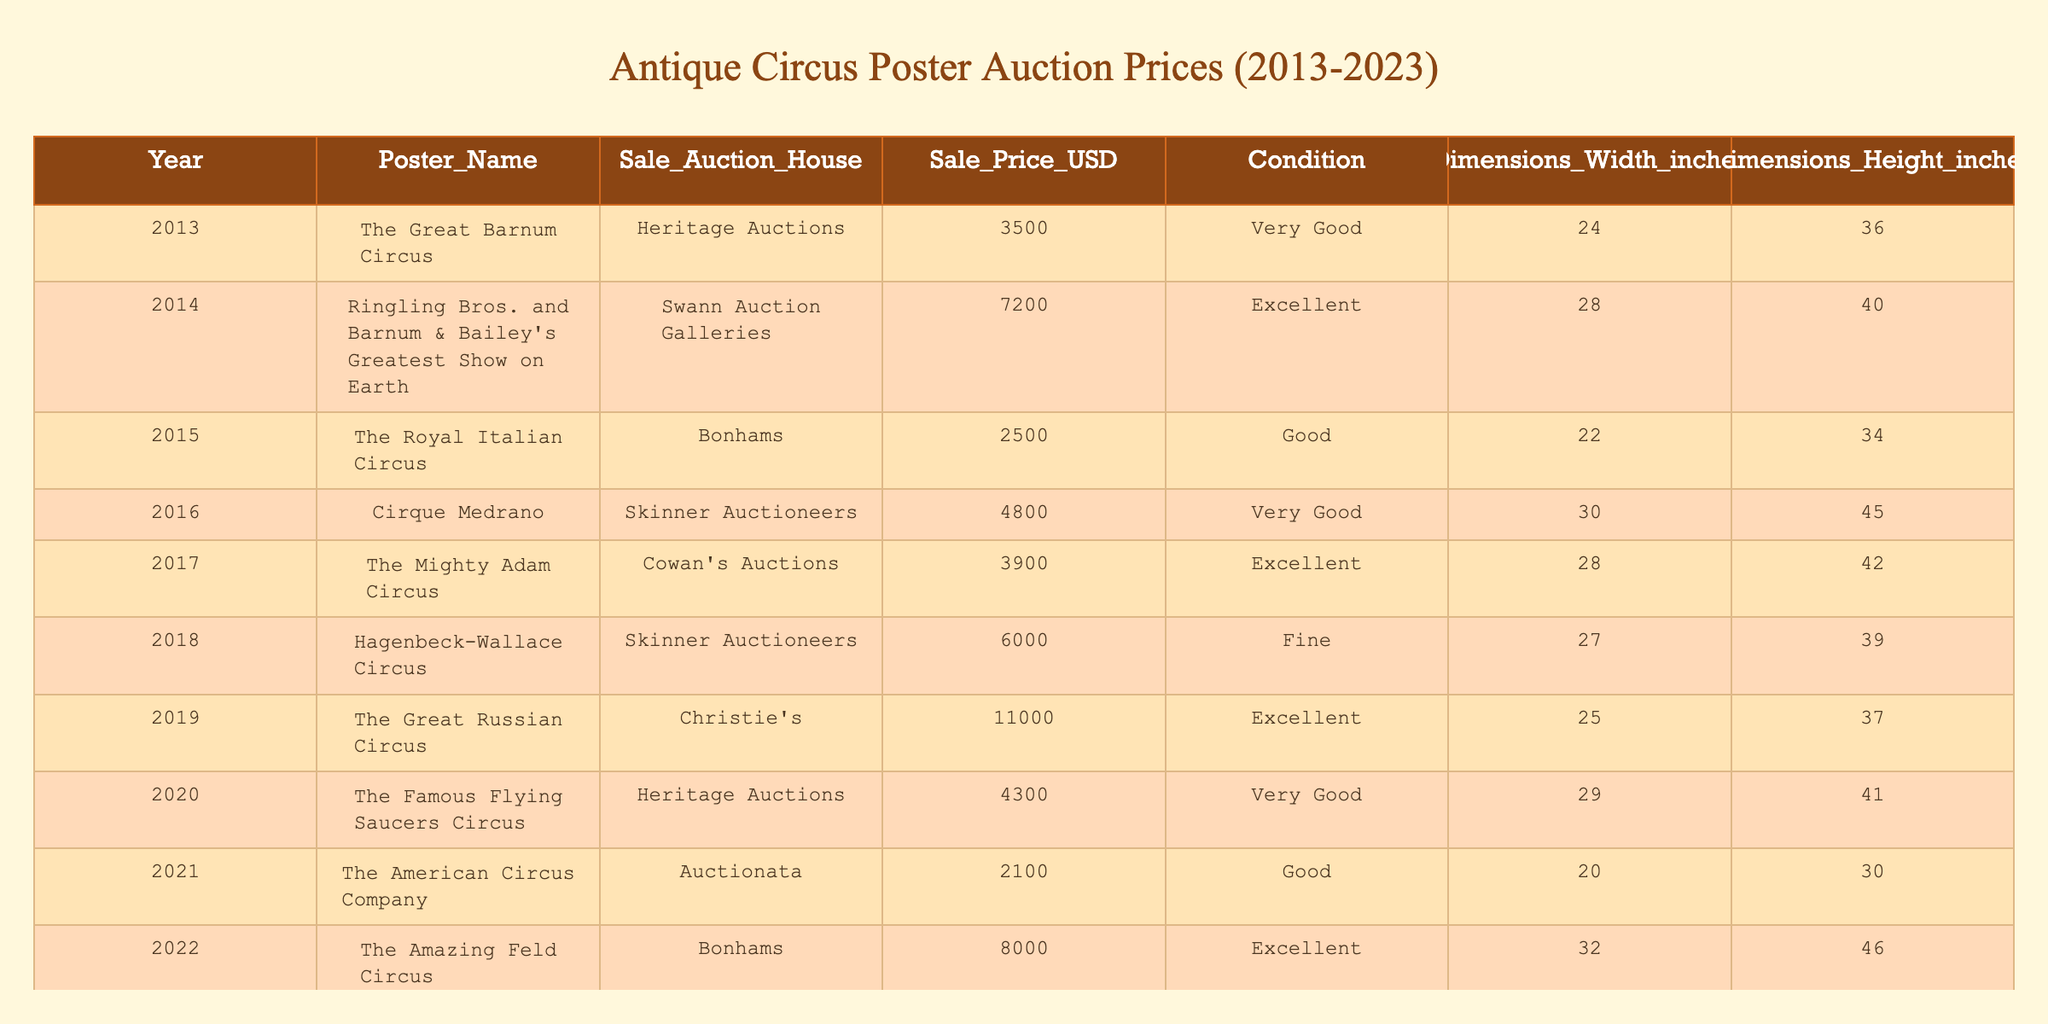What was the sale price of "The Great Russian Circus"? The table shows that "The Great Russian Circus" was sold for 11,000 USD in 2019.
Answer: 11,000 USD What condition was "Daring Diggers Circus" in when it was sold? According to the table, "Daring Diggers Circus" was in "Near Mint" condition when it was sold in 2023.
Answer: Near Mint What was the average sale price of posters in "Excellent" condition? The posters in "Excellent" condition are: "Ringling Bros. and Barnum & Bailey's Greatest Show on Earth" (7,200), "The Mighty Adam Circus" (3,900), "The Great Russian Circus" (11,000), "The Amazing Feld Circus" (8,000), and "Daring Diggers Circus" (9,500). The average is (7,200 + 11,000 + 8,000 + 9,500)/4 = 8,175.
Answer: 8,175 USD Is the sale price of "The American Circus Company" the lowest among all posters? By examining the sale prices in the table, "The American Circus Company" was sold for 2,100 USD, which is lower than all other poster prices listed, confirming it as the lowest.
Answer: Yes What is the difference in sale price between the highest and lowest priced posters? The highest sale price is for "The Great Russian Circus" at 11,000 USD, while the lowest price is for "The American Circus Company" at 2,100 USD. The difference is 11,000 - 2,100 = 8,900 USD.
Answer: 8,900 USD Which auction house sold the most expensive poster and what was the price? "The Great Russian Circus," sold at Christie's for 11,000 USD, is the most expensive poster in the table. Therefore, Christie's is the auction house that sold the most expensive poster.
Answer: Christie's, 11,000 USD How many posters were sold at Skinner Auctioneers? The table shows that there were two posters sold at Skinner Auctioneers: "Cirque Medrano" in 2016 and "Hagenbeck-Wallace Circus" in 2018.
Answer: 2 What was the sale price trend from 2013 to 2023? By examining the sale prices across the years, we observe the following: 3,500 (2013), 7,200 (2014), 2,500 (2015), 4,800 (2016), 3,900 (2017), 6,000 (2018), 11,000 (2019), 4,300 (2020), 2,100 (2021), 8,000 (2022), and 9,500 (2023). The prices fluctuate with notable peaks in 2019 and 2023, but there are also significant drops in 2015 and 2021.
Answer: Fluctuating trend with peaks in 2019 and 2023 What are the dimensions of the poster "The Amazing Feld Circus"? According to the table, "The Amazing Feld Circus" measures 32 inches in width and 46 inches in height when it was sold in 2022.
Answer: 32 x 46 inches 